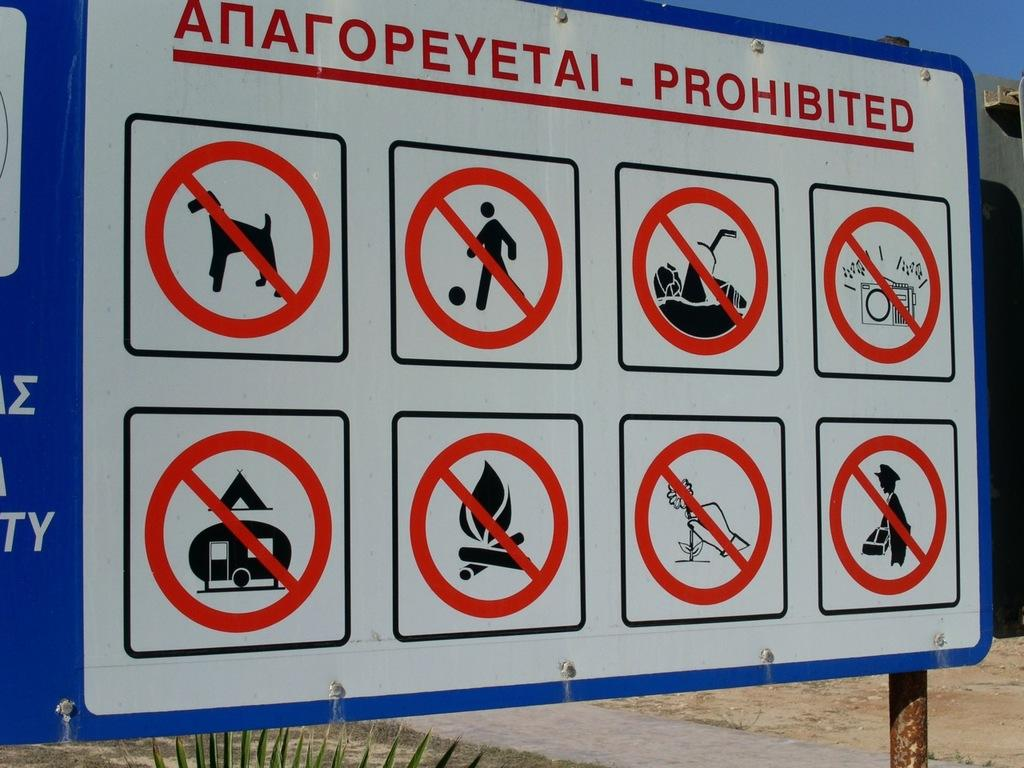<image>
Describe the image concisely. The sign displays all the prohibited behavior at the beach. 